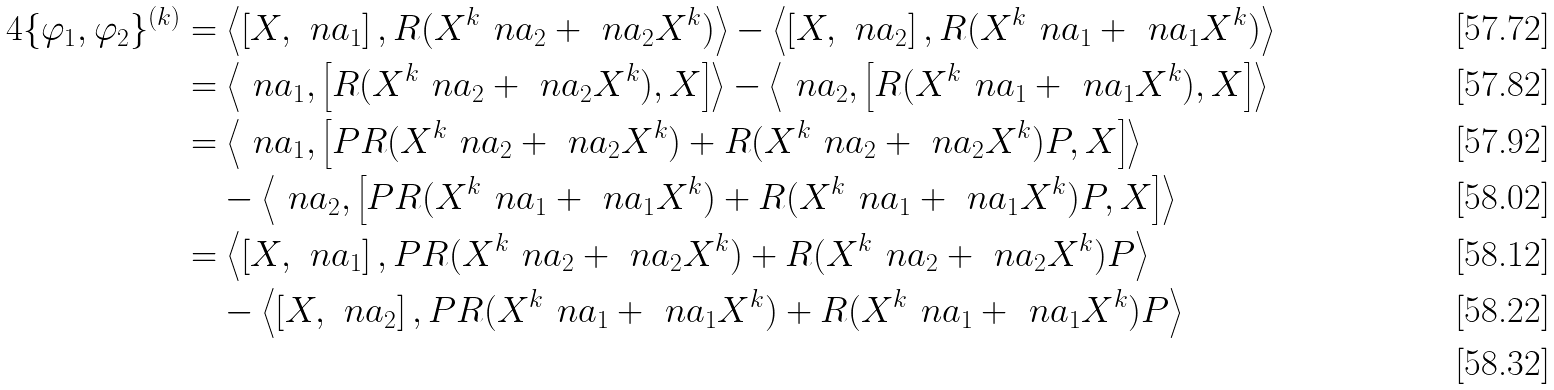Convert formula to latex. <formula><loc_0><loc_0><loc_500><loc_500>4 \{ \varphi _ { 1 } , \varphi _ { 2 } \} ^ { ( k ) } & = \left \langle \left [ X , \ n a _ { 1 } \right ] , R ( X ^ { k } \ n a _ { 2 } + \ n a _ { 2 } X ^ { k } ) \right \rangle - \left \langle \left [ X , \ n a _ { 2 } \right ] , R ( X ^ { k } \ n a _ { 1 } + \ n a _ { 1 } X ^ { k } ) \right \rangle \\ & = \left \langle \ n a _ { 1 } , \left [ R ( X ^ { k } \ n a _ { 2 } + \ n a _ { 2 } X ^ { k } ) , X \right ] \right \rangle - \left \langle \ n a _ { 2 } , \left [ R ( X ^ { k } \ n a _ { 1 } + \ n a _ { 1 } X ^ { k } ) , X \right ] \right \rangle \\ & = \left \langle \ n a _ { 1 } , \left [ P R ( X ^ { k } \ n a _ { 2 } + \ n a _ { 2 } X ^ { k } ) + R ( X ^ { k } \ n a _ { 2 } + \ n a _ { 2 } X ^ { k } ) P , X \right ] \right \rangle \\ & \quad - \left \langle \ n a _ { 2 } , \left [ P R ( X ^ { k } \ n a _ { 1 } + \ n a _ { 1 } X ^ { k } ) + R ( X ^ { k } \ n a _ { 1 } + \ n a _ { 1 } X ^ { k } ) P , X \right ] \right \rangle \\ & = \left \langle \left [ X , \ n a _ { 1 } \right ] , P R ( X ^ { k } \ n a _ { 2 } + \ n a _ { 2 } X ^ { k } ) + R ( X ^ { k } \ n a _ { 2 } + \ n a _ { 2 } X ^ { k } ) P \right \rangle \\ & \quad - \left \langle \left [ X , \ n a _ { 2 } \right ] , P R ( X ^ { k } \ n a _ { 1 } + \ n a _ { 1 } X ^ { k } ) + R ( X ^ { k } \ n a _ { 1 } + \ n a _ { 1 } X ^ { k } ) P \right \rangle \\</formula> 